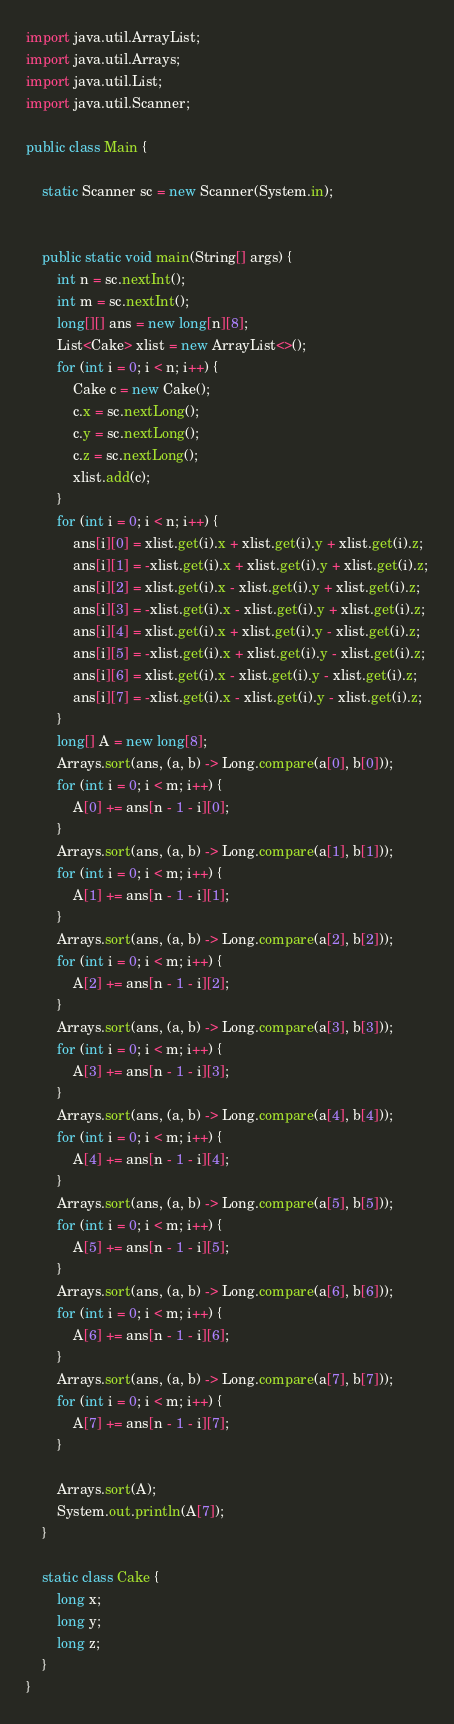<code> <loc_0><loc_0><loc_500><loc_500><_Java_>
import java.util.ArrayList;
import java.util.Arrays;
import java.util.List;
import java.util.Scanner;

public class Main {

    static Scanner sc = new Scanner(System.in);


    public static void main(String[] args) {
        int n = sc.nextInt();
        int m = sc.nextInt();
        long[][] ans = new long[n][8];
        List<Cake> xlist = new ArrayList<>();
        for (int i = 0; i < n; i++) {
            Cake c = new Cake();
            c.x = sc.nextLong();
            c.y = sc.nextLong();
            c.z = sc.nextLong();
            xlist.add(c);
        }
        for (int i = 0; i < n; i++) {
            ans[i][0] = xlist.get(i).x + xlist.get(i).y + xlist.get(i).z;
            ans[i][1] = -xlist.get(i).x + xlist.get(i).y + xlist.get(i).z;
            ans[i][2] = xlist.get(i).x - xlist.get(i).y + xlist.get(i).z;
            ans[i][3] = -xlist.get(i).x - xlist.get(i).y + xlist.get(i).z;
            ans[i][4] = xlist.get(i).x + xlist.get(i).y - xlist.get(i).z;
            ans[i][5] = -xlist.get(i).x + xlist.get(i).y - xlist.get(i).z;
            ans[i][6] = xlist.get(i).x - xlist.get(i).y - xlist.get(i).z;
            ans[i][7] = -xlist.get(i).x - xlist.get(i).y - xlist.get(i).z;
        }
        long[] A = new long[8];
        Arrays.sort(ans, (a, b) -> Long.compare(a[0], b[0]));
        for (int i = 0; i < m; i++) {
            A[0] += ans[n - 1 - i][0];
        }
        Arrays.sort(ans, (a, b) -> Long.compare(a[1], b[1]));
        for (int i = 0; i < m; i++) {
            A[1] += ans[n - 1 - i][1];
        }
        Arrays.sort(ans, (a, b) -> Long.compare(a[2], b[2]));
        for (int i = 0; i < m; i++) {
            A[2] += ans[n - 1 - i][2];
        }
        Arrays.sort(ans, (a, b) -> Long.compare(a[3], b[3]));
        for (int i = 0; i < m; i++) {
            A[3] += ans[n - 1 - i][3];
        }
        Arrays.sort(ans, (a, b) -> Long.compare(a[4], b[4]));
        for (int i = 0; i < m; i++) {
            A[4] += ans[n - 1 - i][4];
        }
        Arrays.sort(ans, (a, b) -> Long.compare(a[5], b[5]));
        for (int i = 0; i < m; i++) {
            A[5] += ans[n - 1 - i][5];
        }
        Arrays.sort(ans, (a, b) -> Long.compare(a[6], b[6]));
        for (int i = 0; i < m; i++) {
            A[6] += ans[n - 1 - i][6];
        }
        Arrays.sort(ans, (a, b) -> Long.compare(a[7], b[7]));
        for (int i = 0; i < m; i++) {
            A[7] += ans[n - 1 - i][7];
        }

        Arrays.sort(A);
        System.out.println(A[7]);
    }

    static class Cake {
        long x;
        long y;
        long z;
    }
}
</code> 